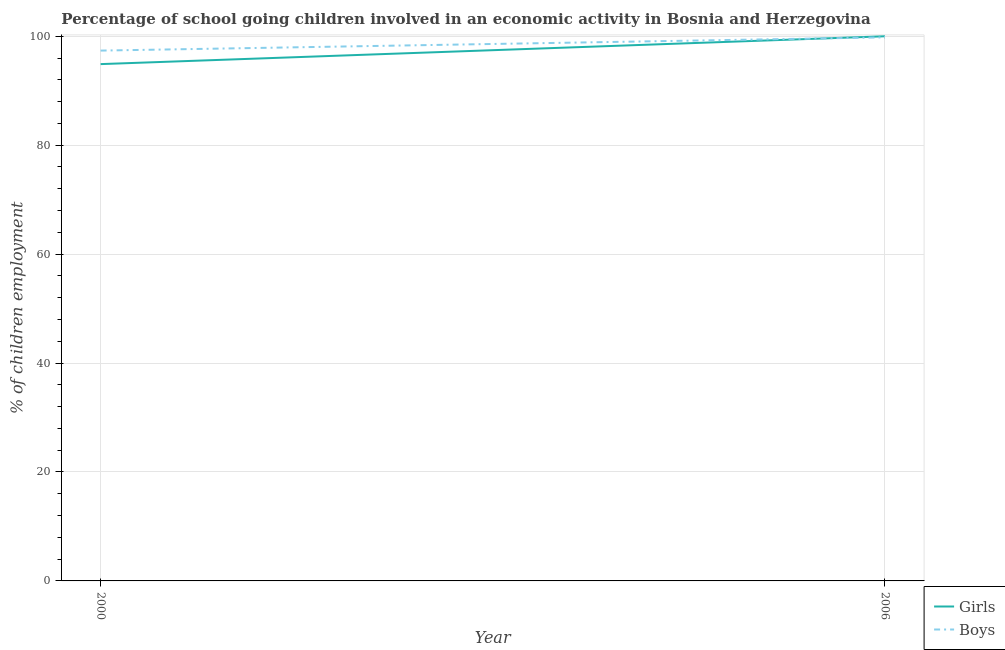Is the number of lines equal to the number of legend labels?
Offer a very short reply. Yes. Across all years, what is the maximum percentage of school going girls?
Ensure brevity in your answer.  100. Across all years, what is the minimum percentage of school going girls?
Keep it short and to the point. 94.89. In which year was the percentage of school going boys maximum?
Offer a terse response. 2006. In which year was the percentage of school going girls minimum?
Your answer should be compact. 2000. What is the total percentage of school going girls in the graph?
Ensure brevity in your answer.  194.89. What is the difference between the percentage of school going boys in 2000 and that in 2006?
Offer a very short reply. -2.43. What is the difference between the percentage of school going boys in 2006 and the percentage of school going girls in 2000?
Give a very brief answer. 4.91. What is the average percentage of school going boys per year?
Offer a very short reply. 98.58. In the year 2006, what is the difference between the percentage of school going girls and percentage of school going boys?
Your response must be concise. 0.2. What is the ratio of the percentage of school going girls in 2000 to that in 2006?
Give a very brief answer. 0.95. Is the percentage of school going boys in 2000 less than that in 2006?
Keep it short and to the point. Yes. Does the percentage of school going boys monotonically increase over the years?
Offer a very short reply. Yes. What is the difference between two consecutive major ticks on the Y-axis?
Give a very brief answer. 20. How many legend labels are there?
Your response must be concise. 2. How are the legend labels stacked?
Your response must be concise. Vertical. What is the title of the graph?
Provide a short and direct response. Percentage of school going children involved in an economic activity in Bosnia and Herzegovina. What is the label or title of the X-axis?
Ensure brevity in your answer.  Year. What is the label or title of the Y-axis?
Your answer should be compact. % of children employment. What is the % of children employment in Girls in 2000?
Offer a terse response. 94.89. What is the % of children employment of Boys in 2000?
Make the answer very short. 97.37. What is the % of children employment of Girls in 2006?
Make the answer very short. 100. What is the % of children employment of Boys in 2006?
Ensure brevity in your answer.  99.8. Across all years, what is the maximum % of children employment of Girls?
Give a very brief answer. 100. Across all years, what is the maximum % of children employment in Boys?
Your response must be concise. 99.8. Across all years, what is the minimum % of children employment of Girls?
Ensure brevity in your answer.  94.89. Across all years, what is the minimum % of children employment in Boys?
Ensure brevity in your answer.  97.37. What is the total % of children employment of Girls in the graph?
Your answer should be very brief. 194.89. What is the total % of children employment in Boys in the graph?
Your answer should be very brief. 197.17. What is the difference between the % of children employment in Girls in 2000 and that in 2006?
Give a very brief answer. -5.11. What is the difference between the % of children employment of Boys in 2000 and that in 2006?
Your answer should be very brief. -2.43. What is the difference between the % of children employment in Girls in 2000 and the % of children employment in Boys in 2006?
Offer a terse response. -4.91. What is the average % of children employment in Girls per year?
Your answer should be very brief. 97.44. What is the average % of children employment of Boys per year?
Offer a very short reply. 98.58. In the year 2000, what is the difference between the % of children employment in Girls and % of children employment in Boys?
Keep it short and to the point. -2.48. In the year 2006, what is the difference between the % of children employment in Girls and % of children employment in Boys?
Ensure brevity in your answer.  0.2. What is the ratio of the % of children employment in Girls in 2000 to that in 2006?
Provide a succinct answer. 0.95. What is the ratio of the % of children employment in Boys in 2000 to that in 2006?
Offer a very short reply. 0.98. What is the difference between the highest and the second highest % of children employment of Girls?
Offer a very short reply. 5.11. What is the difference between the highest and the second highest % of children employment in Boys?
Keep it short and to the point. 2.43. What is the difference between the highest and the lowest % of children employment of Girls?
Make the answer very short. 5.11. What is the difference between the highest and the lowest % of children employment in Boys?
Provide a succinct answer. 2.43. 